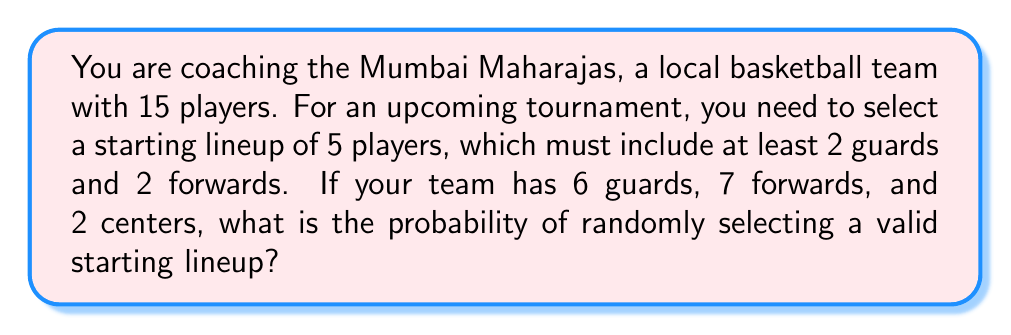Solve this math problem. Let's approach this step-by-step:

1) First, we need to calculate the total number of ways to select 5 players from 15. This is given by the combination formula:

   $$\binom{15}{5} = \frac{15!}{5!(15-5)!} = 3003$$

2) Now, we need to calculate the number of valid lineups. We can break this down into cases:

   Case 1: 2 guards, 2 forwards, 1 center
   Case 2: 2 guards, 3 forwards, 0 centers
   Case 3: 3 guards, 2 forwards, 0 centers

3) For Case 1:
   - Choose 2 guards from 6: $\binom{6}{2}$
   - Choose 2 forwards from 7: $\binom{7}{2}$
   - Choose 1 center from 2: $\binom{2}{1}$

   Total for Case 1: $\binom{6}{2} \cdot \binom{7}{2} \cdot \binom{2}{1} = 15 \cdot 21 \cdot 2 = 630$

4) For Case 2:
   - Choose 2 guards from 6: $\binom{6}{2}$
   - Choose 3 forwards from 7: $\binom{7}{3}$

   Total for Case 2: $\binom{6}{2} \cdot \binom{7}{3} = 15 \cdot 35 = 525$

5) For Case 3:
   - Choose 3 guards from 6: $\binom{6}{3}$
   - Choose 2 forwards from 7: $\binom{7}{2}$

   Total for Case 3: $\binom{6}{3} \cdot \binom{7}{2} = 20 \cdot 21 = 420$

6) The total number of valid lineups is the sum of all cases:
   $630 + 525 + 420 = 1575$

7) The probability is the number of favorable outcomes divided by the total number of possible outcomes:

   $$P(\text{valid lineup}) = \frac{1575}{3003} = \frac{525}{1001} \approx 0.5245$$
Answer: $\frac{525}{1001}$ 